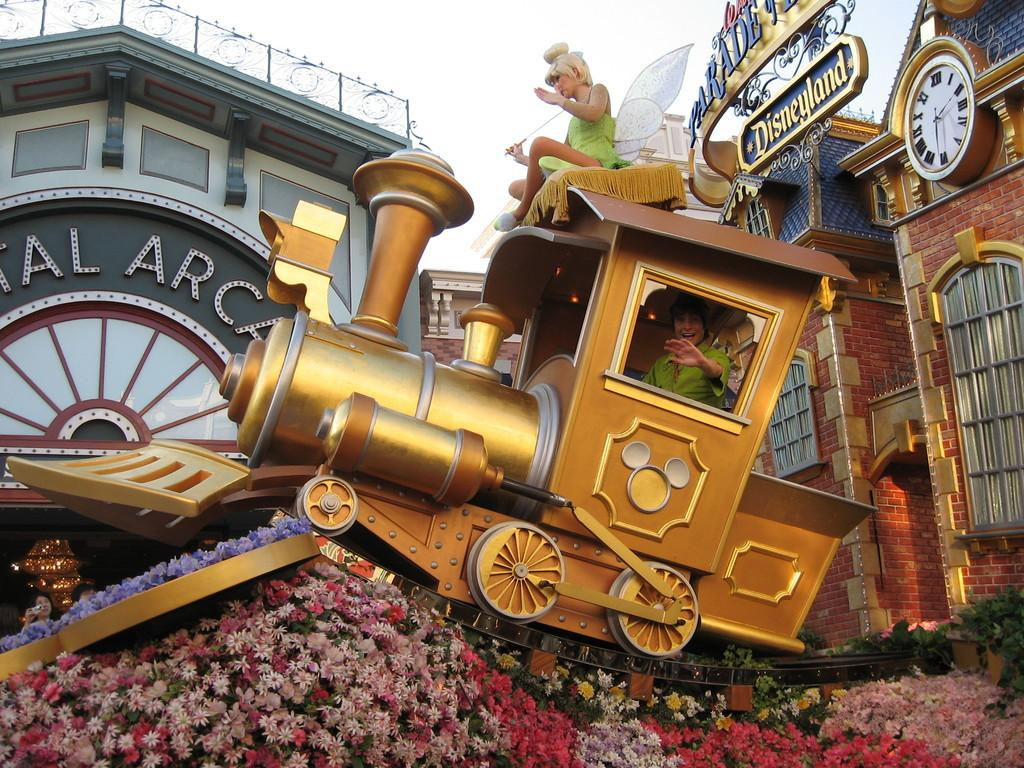<image>
Summarize the visual content of the image. In Disneyland (on the sign) there is a gold train. 